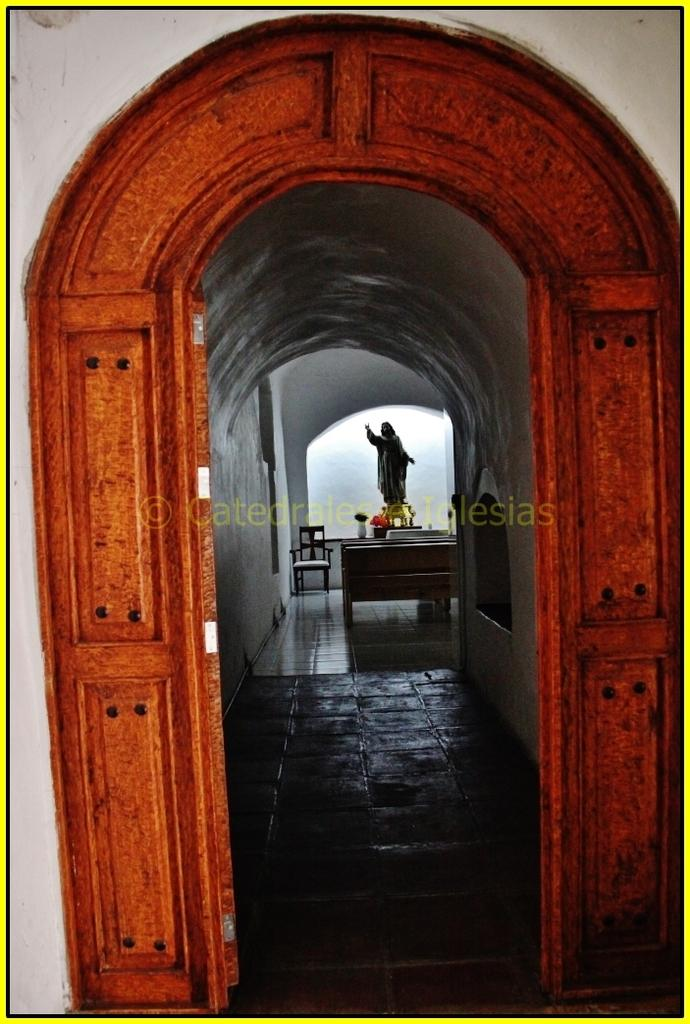What is the primary feature of the image? There is a main entrance in the image. What can be found inside the main entrance? There is a statue inside the main entrance. Are there any seating options near the statue? Yes, there are benches near the statue. Is there any additional seating near the statue? Yes, there is a chair near the wall beside the statue. What type of bread is being offered to the statue in the image? There is no bread present in the image; it features a statue inside a main entrance with benches and a chair nearby. 